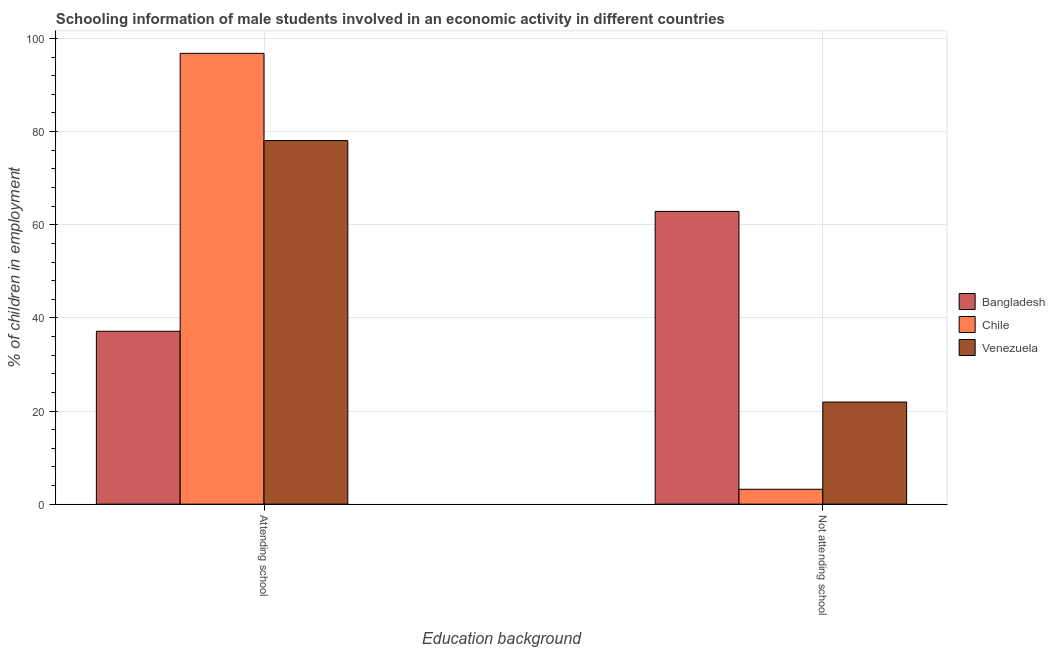How many different coloured bars are there?
Your answer should be very brief. 3. How many bars are there on the 1st tick from the left?
Provide a short and direct response. 3. How many bars are there on the 1st tick from the right?
Your answer should be very brief. 3. What is the label of the 2nd group of bars from the left?
Keep it short and to the point. Not attending school. What is the percentage of employed males who are attending school in Venezuela?
Offer a very short reply. 78.07. Across all countries, what is the maximum percentage of employed males who are not attending school?
Make the answer very short. 62.87. Across all countries, what is the minimum percentage of employed males who are not attending school?
Give a very brief answer. 3.19. What is the total percentage of employed males who are attending school in the graph?
Offer a very short reply. 212.01. What is the difference between the percentage of employed males who are not attending school in Bangladesh and that in Venezuela?
Give a very brief answer. 40.94. What is the difference between the percentage of employed males who are not attending school in Bangladesh and the percentage of employed males who are attending school in Chile?
Your answer should be very brief. -33.94. What is the average percentage of employed males who are not attending school per country?
Provide a short and direct response. 29.33. What is the difference between the percentage of employed males who are attending school and percentage of employed males who are not attending school in Chile?
Your answer should be compact. 93.61. In how many countries, is the percentage of employed males who are not attending school greater than 28 %?
Provide a short and direct response. 1. What is the ratio of the percentage of employed males who are attending school in Venezuela to that in Bangladesh?
Keep it short and to the point. 2.1. What does the 3rd bar from the left in Attending school represents?
Keep it short and to the point. Venezuela. What does the 2nd bar from the right in Attending school represents?
Keep it short and to the point. Chile. How many bars are there?
Offer a terse response. 6. How many countries are there in the graph?
Offer a very short reply. 3. Does the graph contain any zero values?
Your response must be concise. No. Does the graph contain grids?
Provide a succinct answer. Yes. Where does the legend appear in the graph?
Give a very brief answer. Center right. How many legend labels are there?
Your answer should be very brief. 3. What is the title of the graph?
Offer a very short reply. Schooling information of male students involved in an economic activity in different countries. Does "Zimbabwe" appear as one of the legend labels in the graph?
Your answer should be very brief. No. What is the label or title of the X-axis?
Your response must be concise. Education background. What is the label or title of the Y-axis?
Your response must be concise. % of children in employment. What is the % of children in employment in Bangladesh in Attending school?
Give a very brief answer. 37.13. What is the % of children in employment in Chile in Attending school?
Provide a succinct answer. 96.81. What is the % of children in employment of Venezuela in Attending school?
Provide a short and direct response. 78.07. What is the % of children in employment of Bangladesh in Not attending school?
Give a very brief answer. 62.87. What is the % of children in employment of Chile in Not attending school?
Your answer should be very brief. 3.19. What is the % of children in employment in Venezuela in Not attending school?
Offer a terse response. 21.93. Across all Education background, what is the maximum % of children in employment in Bangladesh?
Make the answer very short. 62.87. Across all Education background, what is the maximum % of children in employment in Chile?
Provide a short and direct response. 96.81. Across all Education background, what is the maximum % of children in employment in Venezuela?
Provide a short and direct response. 78.07. Across all Education background, what is the minimum % of children in employment in Bangladesh?
Offer a very short reply. 37.13. Across all Education background, what is the minimum % of children in employment of Chile?
Provide a short and direct response. 3.19. Across all Education background, what is the minimum % of children in employment in Venezuela?
Your answer should be compact. 21.93. What is the total % of children in employment of Bangladesh in the graph?
Your answer should be very brief. 100. What is the total % of children in employment of Chile in the graph?
Your answer should be compact. 100. What is the total % of children in employment of Venezuela in the graph?
Make the answer very short. 100. What is the difference between the % of children in employment of Bangladesh in Attending school and that in Not attending school?
Offer a very short reply. -25.74. What is the difference between the % of children in employment in Chile in Attending school and that in Not attending school?
Your answer should be compact. 93.61. What is the difference between the % of children in employment in Venezuela in Attending school and that in Not attending school?
Provide a succinct answer. 56.14. What is the difference between the % of children in employment in Bangladesh in Attending school and the % of children in employment in Chile in Not attending school?
Your answer should be very brief. 33.94. What is the difference between the % of children in employment in Bangladesh in Attending school and the % of children in employment in Venezuela in Not attending school?
Give a very brief answer. 15.2. What is the difference between the % of children in employment of Chile in Attending school and the % of children in employment of Venezuela in Not attending school?
Your answer should be compact. 74.88. What is the average % of children in employment of Bangladesh per Education background?
Give a very brief answer. 50. What is the average % of children in employment of Chile per Education background?
Keep it short and to the point. 50. What is the average % of children in employment in Venezuela per Education background?
Offer a terse response. 50. What is the difference between the % of children in employment of Bangladesh and % of children in employment of Chile in Attending school?
Give a very brief answer. -59.68. What is the difference between the % of children in employment in Bangladesh and % of children in employment in Venezuela in Attending school?
Give a very brief answer. -40.94. What is the difference between the % of children in employment in Chile and % of children in employment in Venezuela in Attending school?
Keep it short and to the point. 18.74. What is the difference between the % of children in employment in Bangladesh and % of children in employment in Chile in Not attending school?
Keep it short and to the point. 59.68. What is the difference between the % of children in employment in Bangladesh and % of children in employment in Venezuela in Not attending school?
Offer a terse response. 40.94. What is the difference between the % of children in employment in Chile and % of children in employment in Venezuela in Not attending school?
Provide a succinct answer. -18.74. What is the ratio of the % of children in employment of Bangladesh in Attending school to that in Not attending school?
Give a very brief answer. 0.59. What is the ratio of the % of children in employment of Chile in Attending school to that in Not attending school?
Provide a short and direct response. 30.31. What is the ratio of the % of children in employment in Venezuela in Attending school to that in Not attending school?
Give a very brief answer. 3.56. What is the difference between the highest and the second highest % of children in employment of Bangladesh?
Your answer should be very brief. 25.74. What is the difference between the highest and the second highest % of children in employment in Chile?
Give a very brief answer. 93.61. What is the difference between the highest and the second highest % of children in employment of Venezuela?
Provide a succinct answer. 56.14. What is the difference between the highest and the lowest % of children in employment of Bangladesh?
Offer a terse response. 25.74. What is the difference between the highest and the lowest % of children in employment of Chile?
Ensure brevity in your answer.  93.61. What is the difference between the highest and the lowest % of children in employment in Venezuela?
Offer a very short reply. 56.14. 